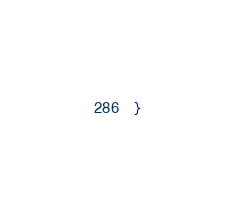<code> <loc_0><loc_0><loc_500><loc_500><_TypeScript_>} 
</code> 